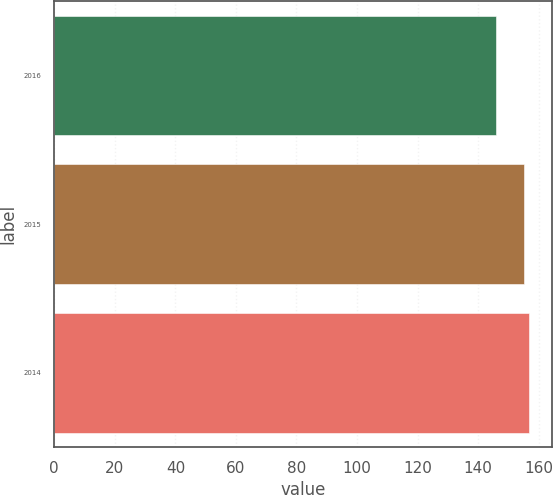Convert chart to OTSL. <chart><loc_0><loc_0><loc_500><loc_500><bar_chart><fcel>2016<fcel>2015<fcel>2014<nl><fcel>146<fcel>155.1<fcel>156.7<nl></chart> 